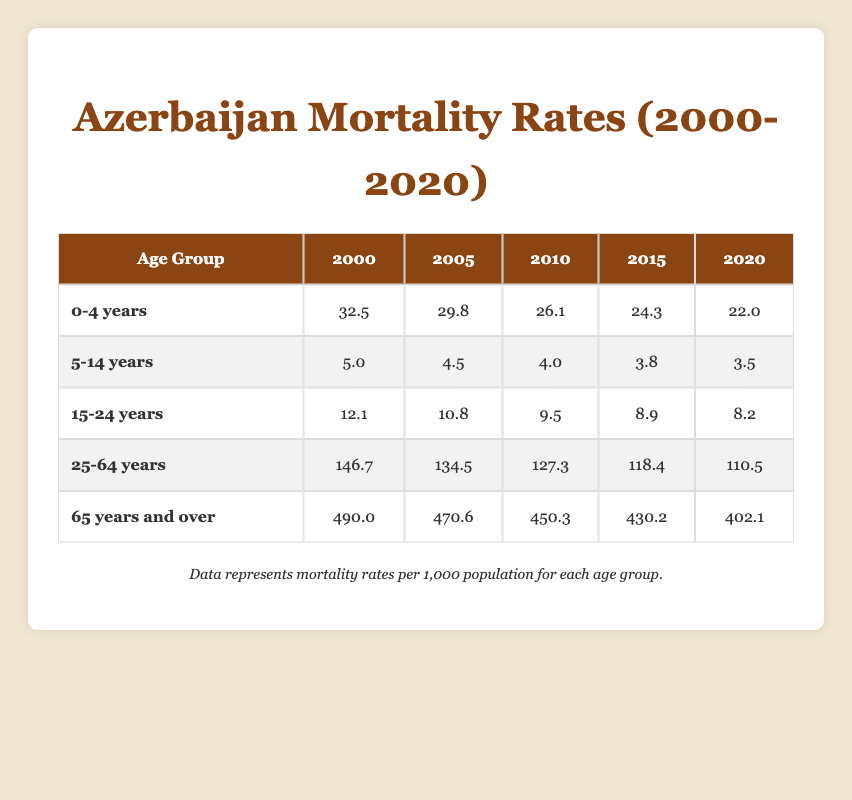What was the mortality rate for the age group of 0-4 years in 2010? According to the table, the mortality rate for the 0-4 years age group in 2010 is listed directly under the year 2010. The value found is 26.1.
Answer: 26.1 What was the lowest mortality rate observed in the age group 5-14 years within the years presented? The table shows mortality rates for the 5-14 years age group across five different years: 5.0 in 2000, 4.5 in 2005, 4.0 in 2010, 3.8 in 2015, and 3.5 in 2020. The lowest value among these is 3.5, observed in 2020.
Answer: 3.5 What is the difference in mortality rates for the age group 15-24 years between the years 2000 and 2020? To find the difference, we take the mortality rate in 2000 (12.1) and subtract the mortality rate in 2020 (8.2). This gives us a difference of 12.1 - 8.2 = 3.9.
Answer: 3.9 Is the mortality rate for the age group 25-64 years decreasing over the years from 2000 to 2020? By reviewing the data from the table, we see that the mortality rates for the age group 25-64 years decreased from 146.7 in 2000 to 110.5 in 2020. This indicates that the mortality rate is indeed decreasing over those years.
Answer: Yes What was the average mortality rate for the age group 65 years and over across all recorded years? To calculate the average, we first add the mortality rates for this age group from each year: 490.0 (2000) + 470.6 (2005) + 450.3 (2010) + 430.2 (2015) + 402.1 (2020) = 2243.2. There are 5 years, so we divide 2243.2 by 5, resulting in an average of 448.64.
Answer: 448.64 What was the highest mortality rate recorded for any age group in the year 2005? We check the table for all age groups in the year 2005. The mortality rates are as follows: 29.8 for 0-4 years, 4.5 for 5-14 years, 10.8 for 15-24 years, 134.5 for 25-64 years, and 470.6 for 65 years and over. The highest value is 470.6 for the 65 years and over age group.
Answer: 470.6 How much did the mortality rate for the age group 0-4 years decline from 2000 to 2020? To find the decline, we subtract the mortality rate in 2020 (22.0) from the one in 2000 (32.5). This gives us a decline of 32.5 - 22.0 = 10.5 over the 20-year period.
Answer: 10.5 Was the mortality rate for the age group 5-14 years lower in 2020 than in 2005? By comparing the values in the table, the mortality rate for 5-14 years was 4.5 in 2005 and 3.5 in 2020. Since 3.5 is less than 4.5, we confirm that it was lower in 2020.
Answer: Yes What is the percentage decrease in mortality rate for the age group 25-64 years from 2000 to 2020? To calculate the percentage decrease, we first find the decrease: 146.7 (2000) - 110.5 (2020) = 36.2. Then, we calculate the percentage decrease: (36.2 / 146.7) * 100, which is approximately 24.7%.
Answer: 24.7% 